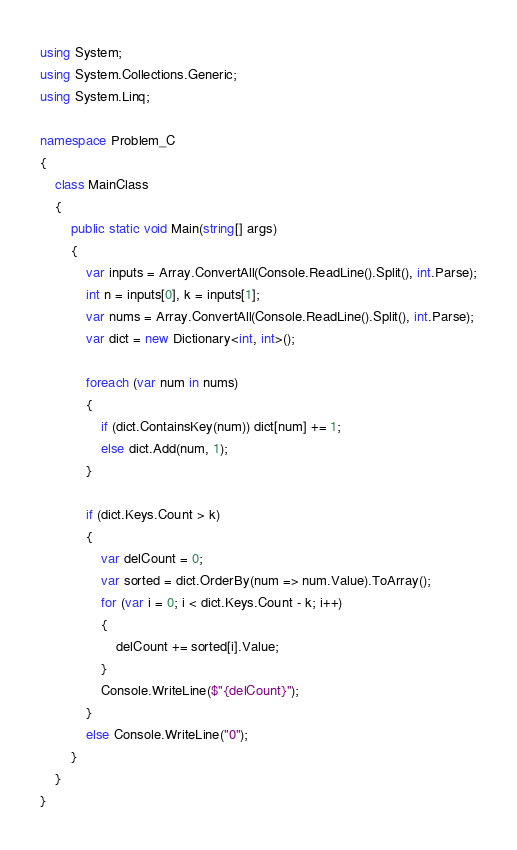Convert code to text. <code><loc_0><loc_0><loc_500><loc_500><_C#_>using System;
using System.Collections.Generic;
using System.Linq;

namespace Problem_C
{
    class MainClass
    {
        public static void Main(string[] args)
        {
            var inputs = Array.ConvertAll(Console.ReadLine().Split(), int.Parse);
            int n = inputs[0], k = inputs[1];
            var nums = Array.ConvertAll(Console.ReadLine().Split(), int.Parse);
            var dict = new Dictionary<int, int>();

            foreach (var num in nums)
            {
                if (dict.ContainsKey(num)) dict[num] += 1;
                else dict.Add(num, 1);
            }

            if (dict.Keys.Count > k)
            {
                var delCount = 0;
                var sorted = dict.OrderBy(num => num.Value).ToArray();
                for (var i = 0; i < dict.Keys.Count - k; i++)
                {
                    delCount += sorted[i].Value;
                }
                Console.WriteLine($"{delCount}");
            }
            else Console.WriteLine("0");
        }
    }
}
</code> 